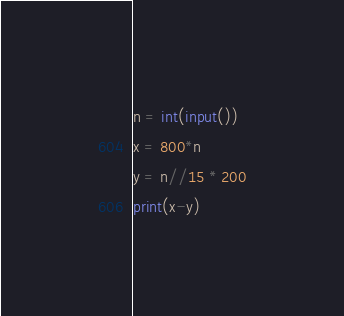Convert code to text. <code><loc_0><loc_0><loc_500><loc_500><_Python_>n = int(input())
x = 800*n
y = n//15 * 200
print(x-y)</code> 